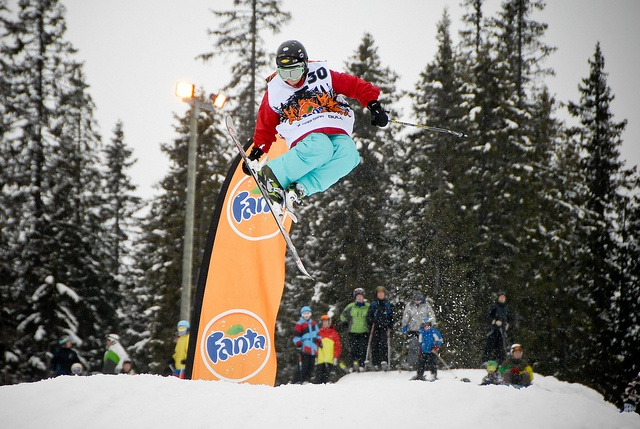Describe the objects in this image and their specific colors. I can see people in darkgray, lavender, lightblue, black, and brown tones, people in darkgray, black, gray, olive, and darkgreen tones, people in darkgray, black, lightblue, gray, and brown tones, people in darkgray, black, and gray tones, and skis in darkgray, lightgray, gray, and black tones in this image. 